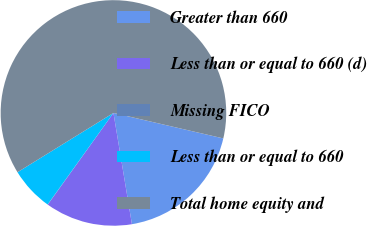Convert chart to OTSL. <chart><loc_0><loc_0><loc_500><loc_500><pie_chart><fcel>Greater than 660<fcel>Less than or equal to 660 (d)<fcel>Missing FICO<fcel>Less than or equal to 660<fcel>Total home equity and<nl><fcel>18.75%<fcel>12.51%<fcel>0.03%<fcel>6.27%<fcel>62.43%<nl></chart> 